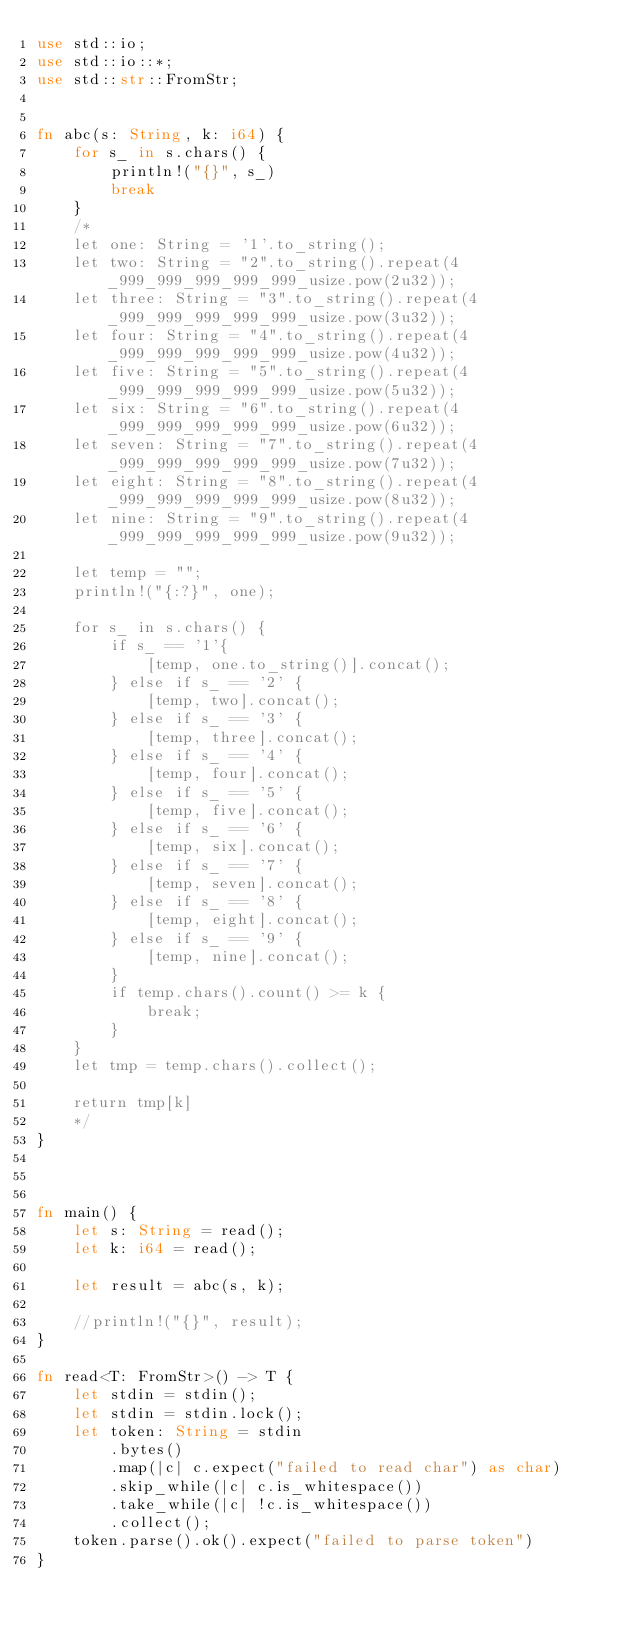Convert code to text. <code><loc_0><loc_0><loc_500><loc_500><_Rust_>use std::io;
use std::io::*;
use std::str::FromStr;
 
 
fn abc(s: String, k: i64) {
    for s_ in s.chars() {
        println!("{}", s_)
        break
    }
    /*
    let one: String = '1'.to_string();
    let two: String = "2".to_string().repeat(4_999_999_999_999_999_usize.pow(2u32));
    let three: String = "3".to_string().repeat(4_999_999_999_999_999_usize.pow(3u32));
    let four: String = "4".to_string().repeat(4_999_999_999_999_999_usize.pow(4u32));
    let five: String = "5".to_string().repeat(4_999_999_999_999_999_usize.pow(5u32));
    let six: String = "6".to_string().repeat(4_999_999_999_999_999_usize.pow(6u32));
    let seven: String = "7".to_string().repeat(4_999_999_999_999_999_usize.pow(7u32));
    let eight: String = "8".to_string().repeat(4_999_999_999_999_999_usize.pow(8u32));
    let nine: String = "9".to_string().repeat(4_999_999_999_999_999_usize.pow(9u32));

    let temp = "";
    println!("{:?}", one);
    
    for s_ in s.chars() {
        if s_ == '1'{
            [temp, one.to_string()].concat();
        } else if s_ == '2' {
            [temp, two].concat();
        } else if s_ == '3' {
            [temp, three].concat();
        } else if s_ == '4' {
            [temp, four].concat();
        } else if s_ == '5' {
            [temp, five].concat();
        } else if s_ == '6' {
            [temp, six].concat();
        } else if s_ == '7' {
            [temp, seven].concat();
        } else if s_ == '8' {
            [temp, eight].concat();
        } else if s_ == '9' {
            [temp, nine].concat();
        }
        if temp.chars().count() >= k {
            break;
        }
    }
    let tmp = temp.chars().collect();
    
    return tmp[k]
    */
}
 

 
fn main() {
    let s: String = read();
    let k: i64 = read();

    let result = abc(s, k);
    
    //println!("{}", result);
}

fn read<T: FromStr>() -> T {
    let stdin = stdin();
    let stdin = stdin.lock();
    let token: String = stdin
        .bytes()
        .map(|c| c.expect("failed to read char") as char) 
        .skip_while(|c| c.is_whitespace())
        .take_while(|c| !c.is_whitespace())
        .collect();
    token.parse().ok().expect("failed to parse token")
}
</code> 